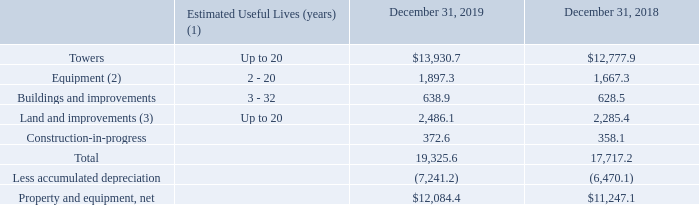AMERICAN TOWER CORPORATION AND SUBSIDIARIES NOTES TO CONSOLIDATED FINANCIAL STATEMENTS (Tabular amounts in millions, unless otherwise disclosed)
3. PROPERTY AND EQUIPMENT
Property and equipment (including assets held under finance leases) consisted of the following:
(1) Assets on leased land are depreciated over the shorter of the estimated useful life of the asset or the term of the corresponding ground lease taking into consideration lease renewal options and residual value.
(2) Includes fiber and DAS assets.
(3) Estimated useful lives apply to improvements only.
What was the estimated useful life of Towers in years? Up to 20. What was the value of Equipment in 2018?
Answer scale should be: million. 1,667.3. What was the value of buildings and improvements in 2019?
Answer scale should be: million. 638.9. What was the change in Land and improvements between 2018 and 2019?
Answer scale should be: million. 2,486.1-2,285.4
Answer: 200.7. What was the change in Construction-in-progress between 2018 and 2019?
Answer scale should be: million. 372.6-358.1
Answer: 14.5. What was the percentage change in Property and equipment, net between 2018 and 2019?
Answer scale should be: percent. ($12,084.4-$11,247.1)/$11,247.1
Answer: 7.44. 